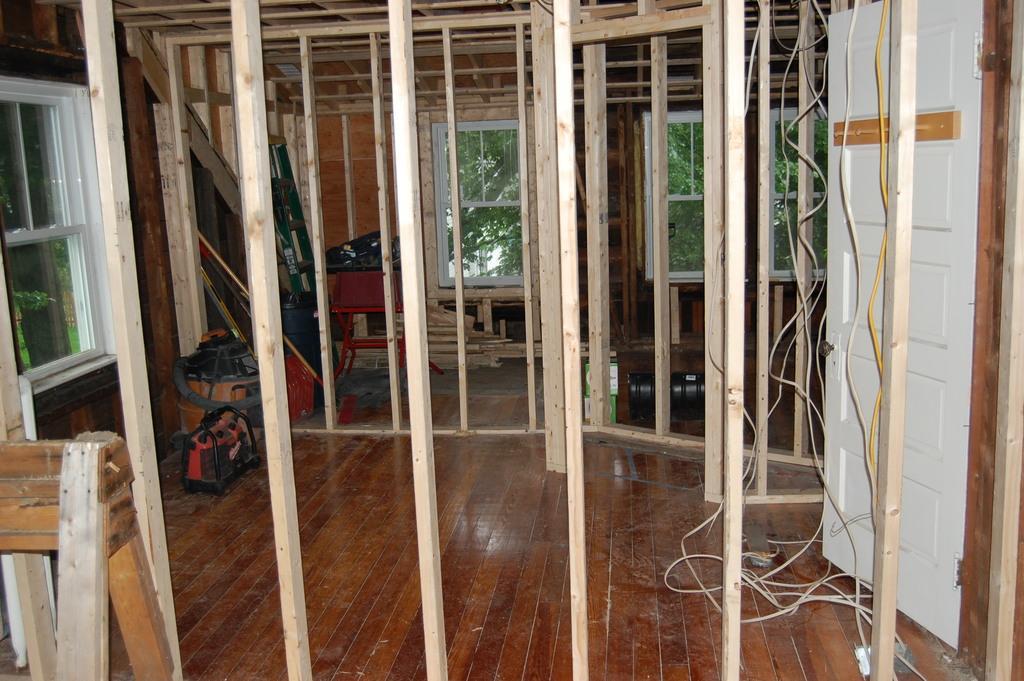Could you give a brief overview of what you see in this image? In this picture I can see the room and hall. On the left I can see the window. In the bank, through the windows I can see the trees. On the right I can see some ropes and cables which are placed near to the door. In the bottom left I can see the wooden sticks. In the center where I can see the bags and other objects. 